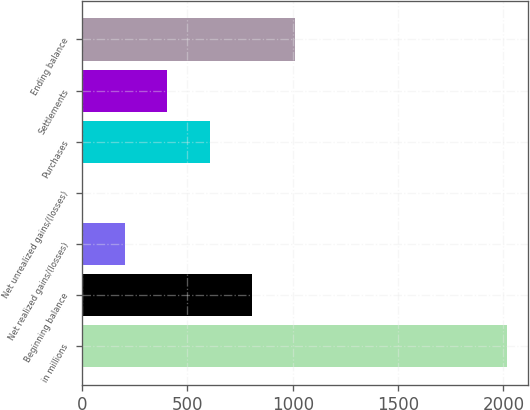Convert chart to OTSL. <chart><loc_0><loc_0><loc_500><loc_500><bar_chart><fcel>in millions<fcel>Beginning balance<fcel>Net realized gains/(losses)<fcel>Net unrealized gains/(losses)<fcel>Purchases<fcel>Settlements<fcel>Ending balance<nl><fcel>2016<fcel>807<fcel>202.5<fcel>1<fcel>605.5<fcel>404<fcel>1008.5<nl></chart> 